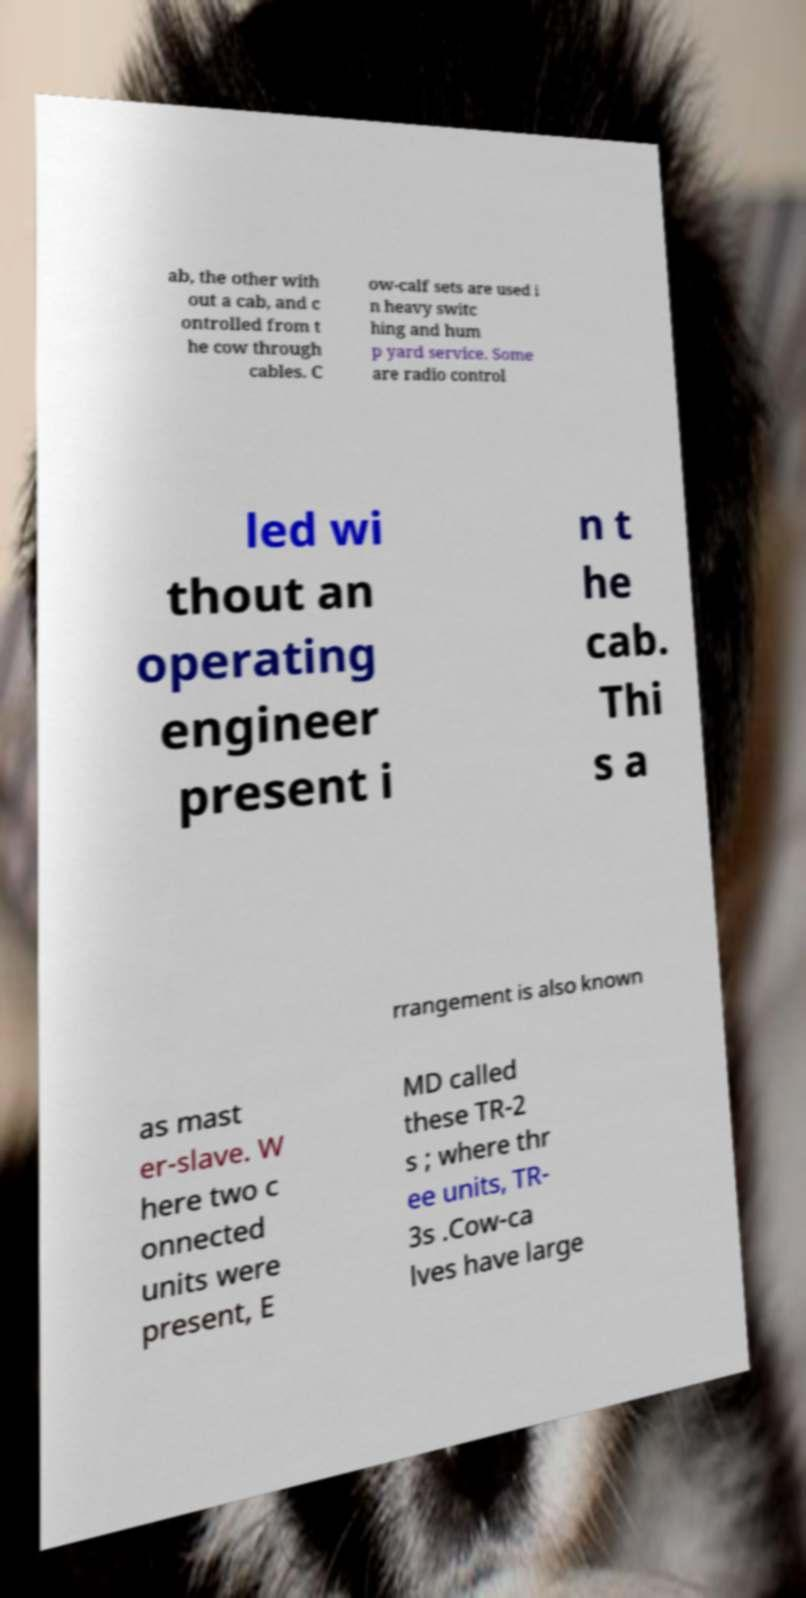For documentation purposes, I need the text within this image transcribed. Could you provide that? ab, the other with out a cab, and c ontrolled from t he cow through cables. C ow-calf sets are used i n heavy switc hing and hum p yard service. Some are radio control led wi thout an operating engineer present i n t he cab. Thi s a rrangement is also known as mast er-slave. W here two c onnected units were present, E MD called these TR-2 s ; where thr ee units, TR- 3s .Cow-ca lves have large 